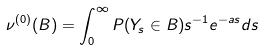Convert formula to latex. <formula><loc_0><loc_0><loc_500><loc_500>\nu ^ { ( 0 ) } ( B ) = \int _ { 0 } ^ { \infty } P ( Y _ { s } \in B ) s ^ { - 1 } e ^ { - a s } d s</formula> 